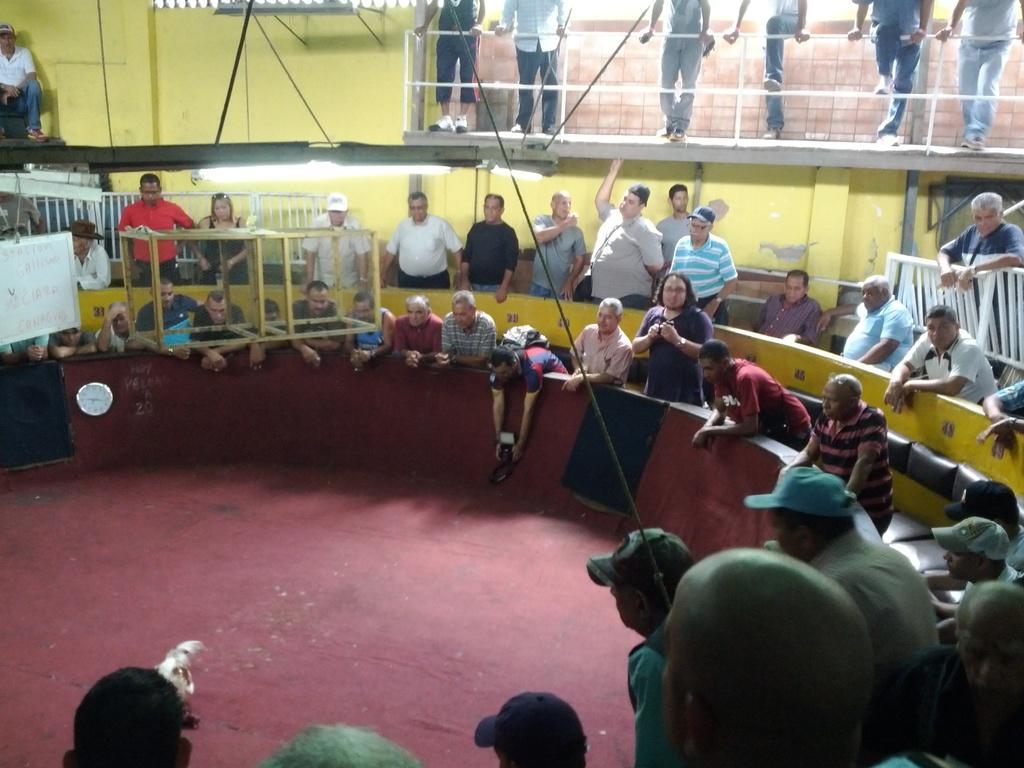How would you summarize this image in a sentence or two? In the background of the image there are people standing. There is wall. There is a light. At the bottom of the image there are people. in the center of the image there is a red color floor. 